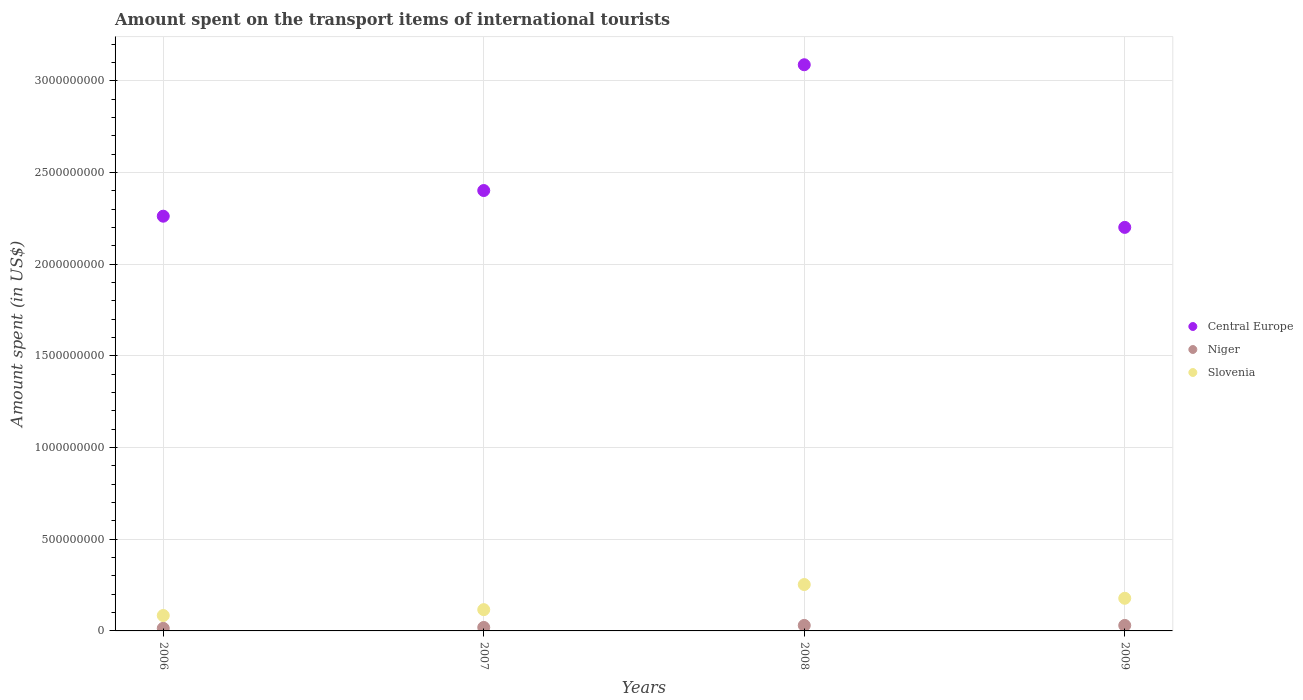How many different coloured dotlines are there?
Make the answer very short. 3. What is the amount spent on the transport items of international tourists in Central Europe in 2007?
Offer a very short reply. 2.40e+09. Across all years, what is the maximum amount spent on the transport items of international tourists in Central Europe?
Keep it short and to the point. 3.09e+09. Across all years, what is the minimum amount spent on the transport items of international tourists in Slovenia?
Make the answer very short. 8.40e+07. In which year was the amount spent on the transport items of international tourists in Central Europe minimum?
Your response must be concise. 2009. What is the total amount spent on the transport items of international tourists in Niger in the graph?
Keep it short and to the point. 9.30e+07. What is the difference between the amount spent on the transport items of international tourists in Central Europe in 2006 and that in 2007?
Offer a terse response. -1.40e+08. What is the difference between the amount spent on the transport items of international tourists in Niger in 2008 and the amount spent on the transport items of international tourists in Slovenia in 2007?
Give a very brief answer. -8.60e+07. What is the average amount spent on the transport items of international tourists in Niger per year?
Your answer should be very brief. 2.32e+07. In the year 2007, what is the difference between the amount spent on the transport items of international tourists in Niger and amount spent on the transport items of international tourists in Slovenia?
Your answer should be very brief. -9.70e+07. In how many years, is the amount spent on the transport items of international tourists in Central Europe greater than 400000000 US$?
Provide a succinct answer. 4. What is the ratio of the amount spent on the transport items of international tourists in Slovenia in 2007 to that in 2008?
Your response must be concise. 0.46. Is the amount spent on the transport items of international tourists in Central Europe in 2006 less than that in 2009?
Give a very brief answer. No. What is the difference between the highest and the second highest amount spent on the transport items of international tourists in Central Europe?
Offer a very short reply. 6.86e+08. What is the difference between the highest and the lowest amount spent on the transport items of international tourists in Central Europe?
Provide a succinct answer. 8.87e+08. In how many years, is the amount spent on the transport items of international tourists in Niger greater than the average amount spent on the transport items of international tourists in Niger taken over all years?
Ensure brevity in your answer.  2. Is the sum of the amount spent on the transport items of international tourists in Slovenia in 2007 and 2008 greater than the maximum amount spent on the transport items of international tourists in Niger across all years?
Offer a terse response. Yes. Is it the case that in every year, the sum of the amount spent on the transport items of international tourists in Central Europe and amount spent on the transport items of international tourists in Slovenia  is greater than the amount spent on the transport items of international tourists in Niger?
Offer a terse response. Yes. Does the amount spent on the transport items of international tourists in Central Europe monotonically increase over the years?
Your answer should be very brief. No. Is the amount spent on the transport items of international tourists in Niger strictly greater than the amount spent on the transport items of international tourists in Central Europe over the years?
Give a very brief answer. No. How many dotlines are there?
Offer a terse response. 3. How many years are there in the graph?
Your answer should be compact. 4. Are the values on the major ticks of Y-axis written in scientific E-notation?
Offer a terse response. No. Does the graph contain any zero values?
Offer a terse response. No. Does the graph contain grids?
Keep it short and to the point. Yes. How are the legend labels stacked?
Ensure brevity in your answer.  Vertical. What is the title of the graph?
Offer a very short reply. Amount spent on the transport items of international tourists. Does "Monaco" appear as one of the legend labels in the graph?
Your answer should be very brief. No. What is the label or title of the Y-axis?
Offer a very short reply. Amount spent (in US$). What is the Amount spent (in US$) of Central Europe in 2006?
Offer a terse response. 2.26e+09. What is the Amount spent (in US$) in Niger in 2006?
Give a very brief answer. 1.40e+07. What is the Amount spent (in US$) in Slovenia in 2006?
Offer a terse response. 8.40e+07. What is the Amount spent (in US$) of Central Europe in 2007?
Make the answer very short. 2.40e+09. What is the Amount spent (in US$) in Niger in 2007?
Make the answer very short. 1.90e+07. What is the Amount spent (in US$) in Slovenia in 2007?
Give a very brief answer. 1.16e+08. What is the Amount spent (in US$) of Central Europe in 2008?
Provide a short and direct response. 3.09e+09. What is the Amount spent (in US$) in Niger in 2008?
Give a very brief answer. 3.00e+07. What is the Amount spent (in US$) of Slovenia in 2008?
Your answer should be very brief. 2.53e+08. What is the Amount spent (in US$) of Central Europe in 2009?
Ensure brevity in your answer.  2.20e+09. What is the Amount spent (in US$) of Niger in 2009?
Ensure brevity in your answer.  3.00e+07. What is the Amount spent (in US$) in Slovenia in 2009?
Provide a succinct answer. 1.78e+08. Across all years, what is the maximum Amount spent (in US$) of Central Europe?
Give a very brief answer. 3.09e+09. Across all years, what is the maximum Amount spent (in US$) of Niger?
Give a very brief answer. 3.00e+07. Across all years, what is the maximum Amount spent (in US$) in Slovenia?
Keep it short and to the point. 2.53e+08. Across all years, what is the minimum Amount spent (in US$) in Central Europe?
Offer a terse response. 2.20e+09. Across all years, what is the minimum Amount spent (in US$) of Niger?
Provide a succinct answer. 1.40e+07. Across all years, what is the minimum Amount spent (in US$) in Slovenia?
Give a very brief answer. 8.40e+07. What is the total Amount spent (in US$) of Central Europe in the graph?
Provide a succinct answer. 9.95e+09. What is the total Amount spent (in US$) of Niger in the graph?
Your answer should be very brief. 9.30e+07. What is the total Amount spent (in US$) of Slovenia in the graph?
Your answer should be compact. 6.31e+08. What is the difference between the Amount spent (in US$) of Central Europe in 2006 and that in 2007?
Provide a short and direct response. -1.40e+08. What is the difference between the Amount spent (in US$) of Niger in 2006 and that in 2007?
Ensure brevity in your answer.  -5.00e+06. What is the difference between the Amount spent (in US$) of Slovenia in 2006 and that in 2007?
Your response must be concise. -3.20e+07. What is the difference between the Amount spent (in US$) of Central Europe in 2006 and that in 2008?
Keep it short and to the point. -8.26e+08. What is the difference between the Amount spent (in US$) in Niger in 2006 and that in 2008?
Offer a very short reply. -1.60e+07. What is the difference between the Amount spent (in US$) of Slovenia in 2006 and that in 2008?
Provide a succinct answer. -1.69e+08. What is the difference between the Amount spent (in US$) of Central Europe in 2006 and that in 2009?
Your response must be concise. 6.10e+07. What is the difference between the Amount spent (in US$) in Niger in 2006 and that in 2009?
Your answer should be very brief. -1.60e+07. What is the difference between the Amount spent (in US$) in Slovenia in 2006 and that in 2009?
Keep it short and to the point. -9.40e+07. What is the difference between the Amount spent (in US$) of Central Europe in 2007 and that in 2008?
Ensure brevity in your answer.  -6.86e+08. What is the difference between the Amount spent (in US$) in Niger in 2007 and that in 2008?
Your answer should be compact. -1.10e+07. What is the difference between the Amount spent (in US$) in Slovenia in 2007 and that in 2008?
Provide a succinct answer. -1.37e+08. What is the difference between the Amount spent (in US$) of Central Europe in 2007 and that in 2009?
Your answer should be very brief. 2.01e+08. What is the difference between the Amount spent (in US$) in Niger in 2007 and that in 2009?
Provide a succinct answer. -1.10e+07. What is the difference between the Amount spent (in US$) of Slovenia in 2007 and that in 2009?
Keep it short and to the point. -6.20e+07. What is the difference between the Amount spent (in US$) of Central Europe in 2008 and that in 2009?
Keep it short and to the point. 8.87e+08. What is the difference between the Amount spent (in US$) of Niger in 2008 and that in 2009?
Keep it short and to the point. 0. What is the difference between the Amount spent (in US$) in Slovenia in 2008 and that in 2009?
Ensure brevity in your answer.  7.50e+07. What is the difference between the Amount spent (in US$) in Central Europe in 2006 and the Amount spent (in US$) in Niger in 2007?
Provide a short and direct response. 2.24e+09. What is the difference between the Amount spent (in US$) in Central Europe in 2006 and the Amount spent (in US$) in Slovenia in 2007?
Give a very brief answer. 2.15e+09. What is the difference between the Amount spent (in US$) in Niger in 2006 and the Amount spent (in US$) in Slovenia in 2007?
Offer a very short reply. -1.02e+08. What is the difference between the Amount spent (in US$) in Central Europe in 2006 and the Amount spent (in US$) in Niger in 2008?
Give a very brief answer. 2.23e+09. What is the difference between the Amount spent (in US$) of Central Europe in 2006 and the Amount spent (in US$) of Slovenia in 2008?
Ensure brevity in your answer.  2.01e+09. What is the difference between the Amount spent (in US$) of Niger in 2006 and the Amount spent (in US$) of Slovenia in 2008?
Offer a terse response. -2.39e+08. What is the difference between the Amount spent (in US$) of Central Europe in 2006 and the Amount spent (in US$) of Niger in 2009?
Provide a short and direct response. 2.23e+09. What is the difference between the Amount spent (in US$) of Central Europe in 2006 and the Amount spent (in US$) of Slovenia in 2009?
Make the answer very short. 2.08e+09. What is the difference between the Amount spent (in US$) of Niger in 2006 and the Amount spent (in US$) of Slovenia in 2009?
Provide a succinct answer. -1.64e+08. What is the difference between the Amount spent (in US$) of Central Europe in 2007 and the Amount spent (in US$) of Niger in 2008?
Ensure brevity in your answer.  2.37e+09. What is the difference between the Amount spent (in US$) in Central Europe in 2007 and the Amount spent (in US$) in Slovenia in 2008?
Give a very brief answer. 2.15e+09. What is the difference between the Amount spent (in US$) of Niger in 2007 and the Amount spent (in US$) of Slovenia in 2008?
Keep it short and to the point. -2.34e+08. What is the difference between the Amount spent (in US$) in Central Europe in 2007 and the Amount spent (in US$) in Niger in 2009?
Make the answer very short. 2.37e+09. What is the difference between the Amount spent (in US$) in Central Europe in 2007 and the Amount spent (in US$) in Slovenia in 2009?
Offer a very short reply. 2.22e+09. What is the difference between the Amount spent (in US$) of Niger in 2007 and the Amount spent (in US$) of Slovenia in 2009?
Give a very brief answer. -1.59e+08. What is the difference between the Amount spent (in US$) in Central Europe in 2008 and the Amount spent (in US$) in Niger in 2009?
Keep it short and to the point. 3.06e+09. What is the difference between the Amount spent (in US$) of Central Europe in 2008 and the Amount spent (in US$) of Slovenia in 2009?
Your answer should be very brief. 2.91e+09. What is the difference between the Amount spent (in US$) of Niger in 2008 and the Amount spent (in US$) of Slovenia in 2009?
Your answer should be compact. -1.48e+08. What is the average Amount spent (in US$) in Central Europe per year?
Provide a short and direct response. 2.49e+09. What is the average Amount spent (in US$) in Niger per year?
Your answer should be compact. 2.32e+07. What is the average Amount spent (in US$) of Slovenia per year?
Your answer should be compact. 1.58e+08. In the year 2006, what is the difference between the Amount spent (in US$) in Central Europe and Amount spent (in US$) in Niger?
Provide a short and direct response. 2.25e+09. In the year 2006, what is the difference between the Amount spent (in US$) in Central Europe and Amount spent (in US$) in Slovenia?
Offer a terse response. 2.18e+09. In the year 2006, what is the difference between the Amount spent (in US$) of Niger and Amount spent (in US$) of Slovenia?
Ensure brevity in your answer.  -7.00e+07. In the year 2007, what is the difference between the Amount spent (in US$) of Central Europe and Amount spent (in US$) of Niger?
Ensure brevity in your answer.  2.38e+09. In the year 2007, what is the difference between the Amount spent (in US$) in Central Europe and Amount spent (in US$) in Slovenia?
Give a very brief answer. 2.29e+09. In the year 2007, what is the difference between the Amount spent (in US$) of Niger and Amount spent (in US$) of Slovenia?
Provide a short and direct response. -9.70e+07. In the year 2008, what is the difference between the Amount spent (in US$) in Central Europe and Amount spent (in US$) in Niger?
Offer a very short reply. 3.06e+09. In the year 2008, what is the difference between the Amount spent (in US$) of Central Europe and Amount spent (in US$) of Slovenia?
Your answer should be very brief. 2.84e+09. In the year 2008, what is the difference between the Amount spent (in US$) of Niger and Amount spent (in US$) of Slovenia?
Offer a very short reply. -2.23e+08. In the year 2009, what is the difference between the Amount spent (in US$) in Central Europe and Amount spent (in US$) in Niger?
Offer a terse response. 2.17e+09. In the year 2009, what is the difference between the Amount spent (in US$) of Central Europe and Amount spent (in US$) of Slovenia?
Your answer should be very brief. 2.02e+09. In the year 2009, what is the difference between the Amount spent (in US$) of Niger and Amount spent (in US$) of Slovenia?
Your answer should be compact. -1.48e+08. What is the ratio of the Amount spent (in US$) of Central Europe in 2006 to that in 2007?
Your answer should be compact. 0.94. What is the ratio of the Amount spent (in US$) in Niger in 2006 to that in 2007?
Make the answer very short. 0.74. What is the ratio of the Amount spent (in US$) in Slovenia in 2006 to that in 2007?
Keep it short and to the point. 0.72. What is the ratio of the Amount spent (in US$) of Central Europe in 2006 to that in 2008?
Make the answer very short. 0.73. What is the ratio of the Amount spent (in US$) in Niger in 2006 to that in 2008?
Your answer should be very brief. 0.47. What is the ratio of the Amount spent (in US$) in Slovenia in 2006 to that in 2008?
Provide a short and direct response. 0.33. What is the ratio of the Amount spent (in US$) of Central Europe in 2006 to that in 2009?
Ensure brevity in your answer.  1.03. What is the ratio of the Amount spent (in US$) in Niger in 2006 to that in 2009?
Provide a short and direct response. 0.47. What is the ratio of the Amount spent (in US$) in Slovenia in 2006 to that in 2009?
Your response must be concise. 0.47. What is the ratio of the Amount spent (in US$) in Niger in 2007 to that in 2008?
Your response must be concise. 0.63. What is the ratio of the Amount spent (in US$) in Slovenia in 2007 to that in 2008?
Offer a very short reply. 0.46. What is the ratio of the Amount spent (in US$) in Central Europe in 2007 to that in 2009?
Ensure brevity in your answer.  1.09. What is the ratio of the Amount spent (in US$) of Niger in 2007 to that in 2009?
Make the answer very short. 0.63. What is the ratio of the Amount spent (in US$) of Slovenia in 2007 to that in 2009?
Ensure brevity in your answer.  0.65. What is the ratio of the Amount spent (in US$) of Central Europe in 2008 to that in 2009?
Your response must be concise. 1.4. What is the ratio of the Amount spent (in US$) of Niger in 2008 to that in 2009?
Provide a short and direct response. 1. What is the ratio of the Amount spent (in US$) of Slovenia in 2008 to that in 2009?
Your answer should be very brief. 1.42. What is the difference between the highest and the second highest Amount spent (in US$) in Central Europe?
Make the answer very short. 6.86e+08. What is the difference between the highest and the second highest Amount spent (in US$) in Niger?
Offer a very short reply. 0. What is the difference between the highest and the second highest Amount spent (in US$) of Slovenia?
Your answer should be very brief. 7.50e+07. What is the difference between the highest and the lowest Amount spent (in US$) in Central Europe?
Make the answer very short. 8.87e+08. What is the difference between the highest and the lowest Amount spent (in US$) in Niger?
Offer a very short reply. 1.60e+07. What is the difference between the highest and the lowest Amount spent (in US$) in Slovenia?
Provide a succinct answer. 1.69e+08. 